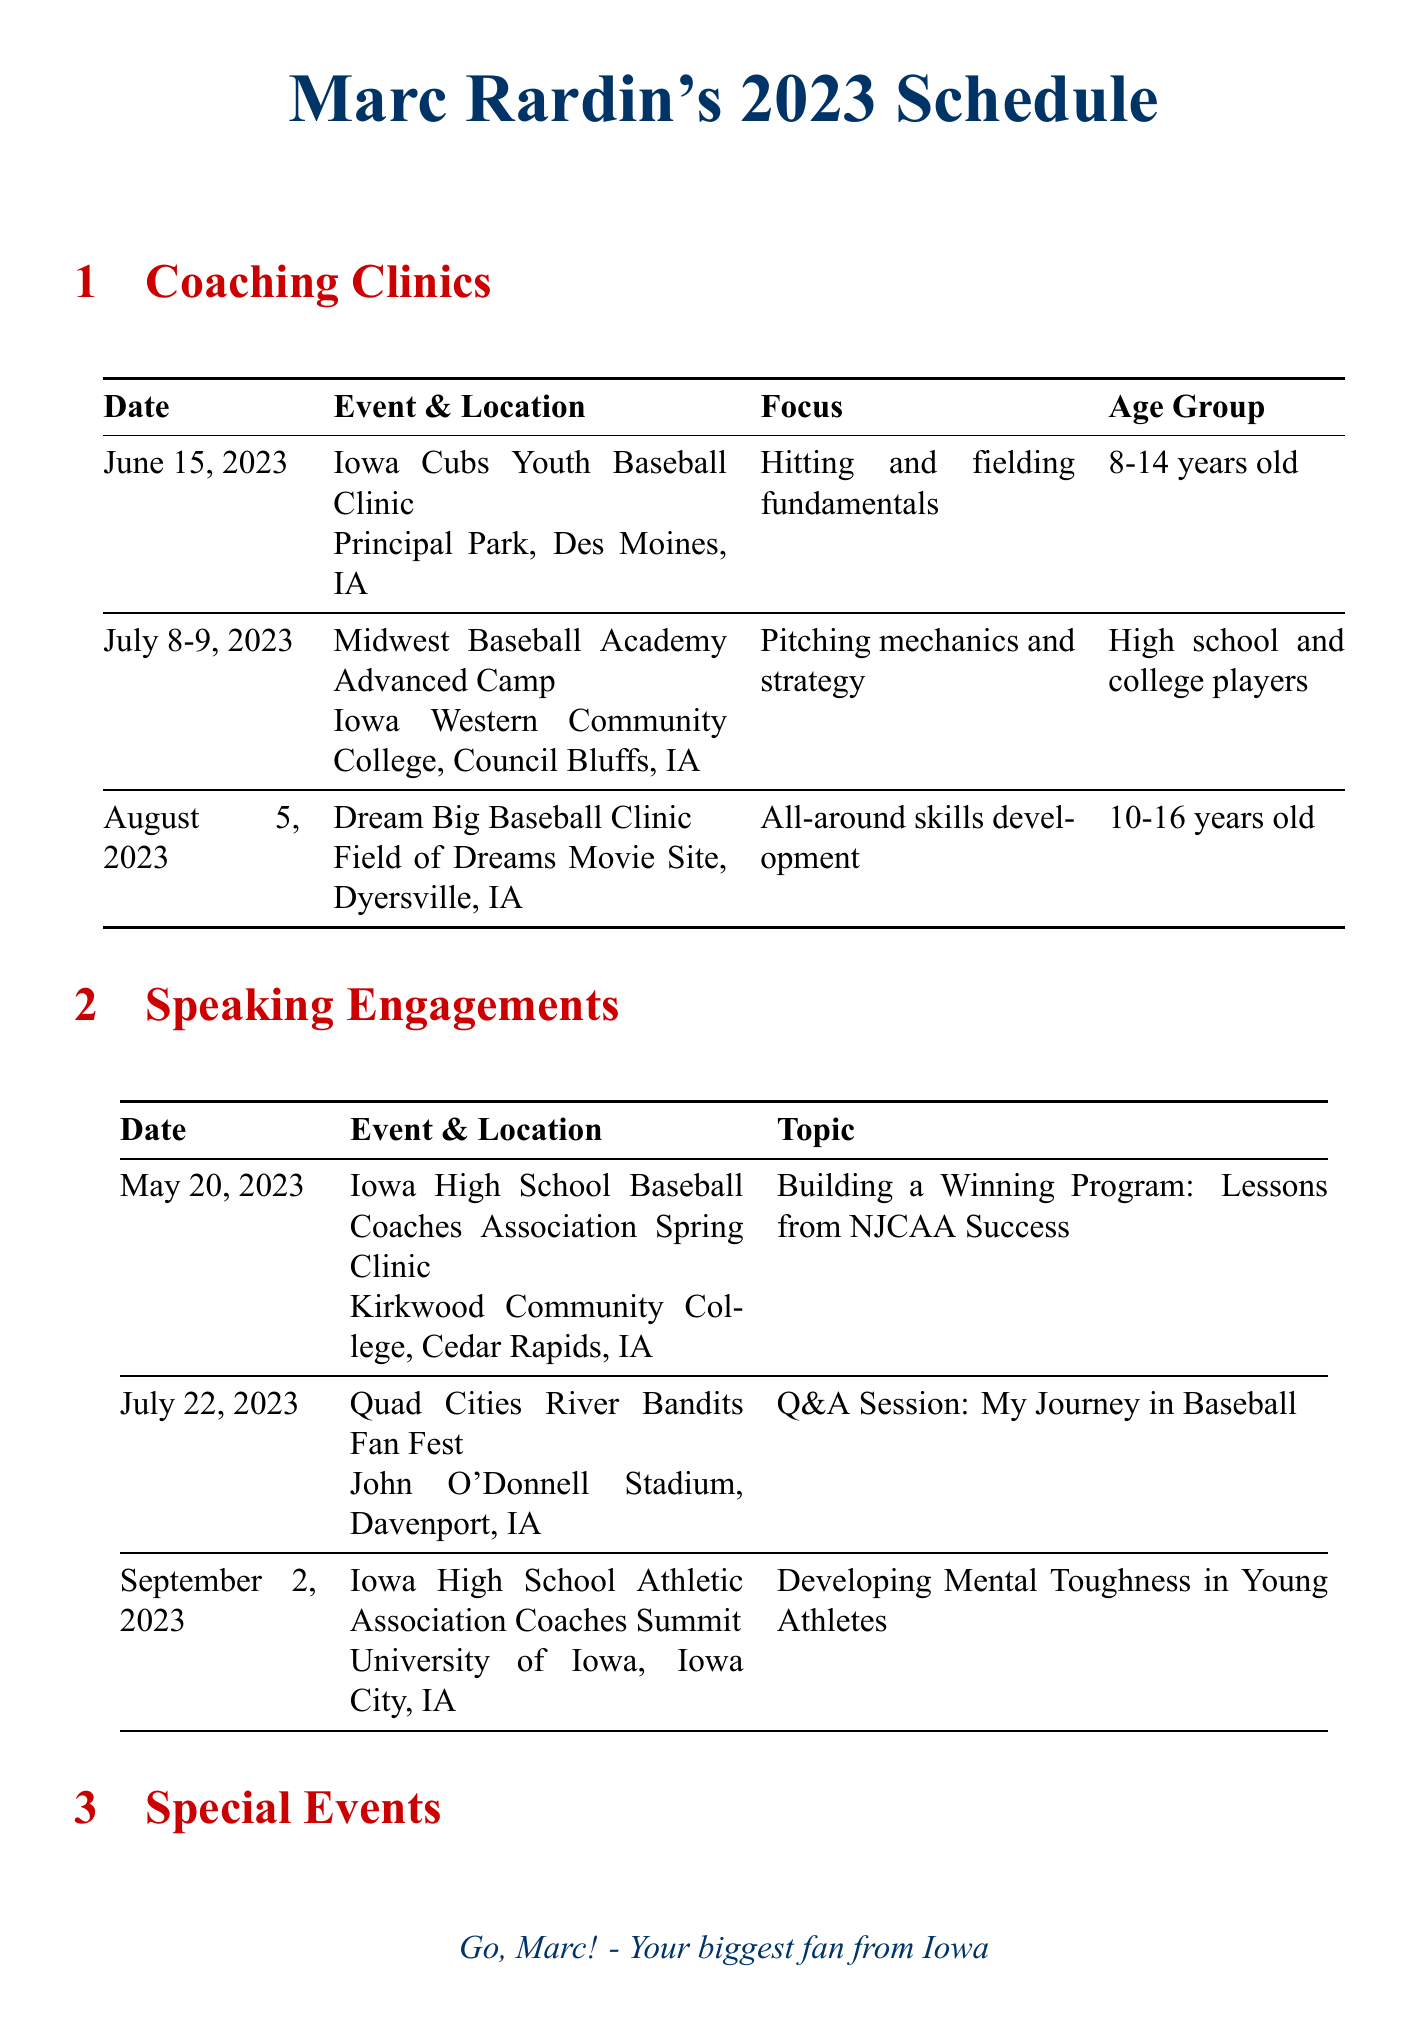What is the date of the Iowa Cubs Youth Baseball Clinic? The date is found in the coaching clinics section of the document, which lists the clinic on June 15, 2023.
Answer: June 15, 2023 Where will the Midwest Baseball Academy Advanced Camp take place? The location is available in the coaching clinics section, specifically stating Iowa Western Community College, Council Bluffs, IA.
Answer: Iowa Western Community College, Council Bluffs, IA What is the focus of the Dream Big Baseball Clinic? The focus is described in the coaching clinics section as all-around skills development.
Answer: All-around skills development What is the topic of Marc Rardin's speaking engagement on September 2, 2023? The topic can be found in the speaking engagements section, which states: Developing Mental Toughness in Young Athletes.
Answer: Developing Mental Toughness in Young Athletes How many special events are listed in the document? The number of special events can be counted from the special events section, where two events are mentioned.
Answer: 2 What will Marc Rardin do at the Cedar Rapids Kernels pre-game ceremony? The description in the special events section indicates that he will throw out the first pitch and sign autographs.
Answer: Throw out first pitch and sign autographs Which speaking engagement is scheduled for July 22, 2023? The specific event is noted in the speaking engagements section, alongside its date and topic: Quad Cities River Bandits Fan Fest and Q&A Session: My Journey in Baseball.
Answer: Quad Cities River Bandits Fan Fest What is the age group for the Iowa Cubs Youth Baseball Clinic? The age group is detailed in the coaching clinics section, which specifies it as 8-14 years old.
Answer: 8-14 years old 